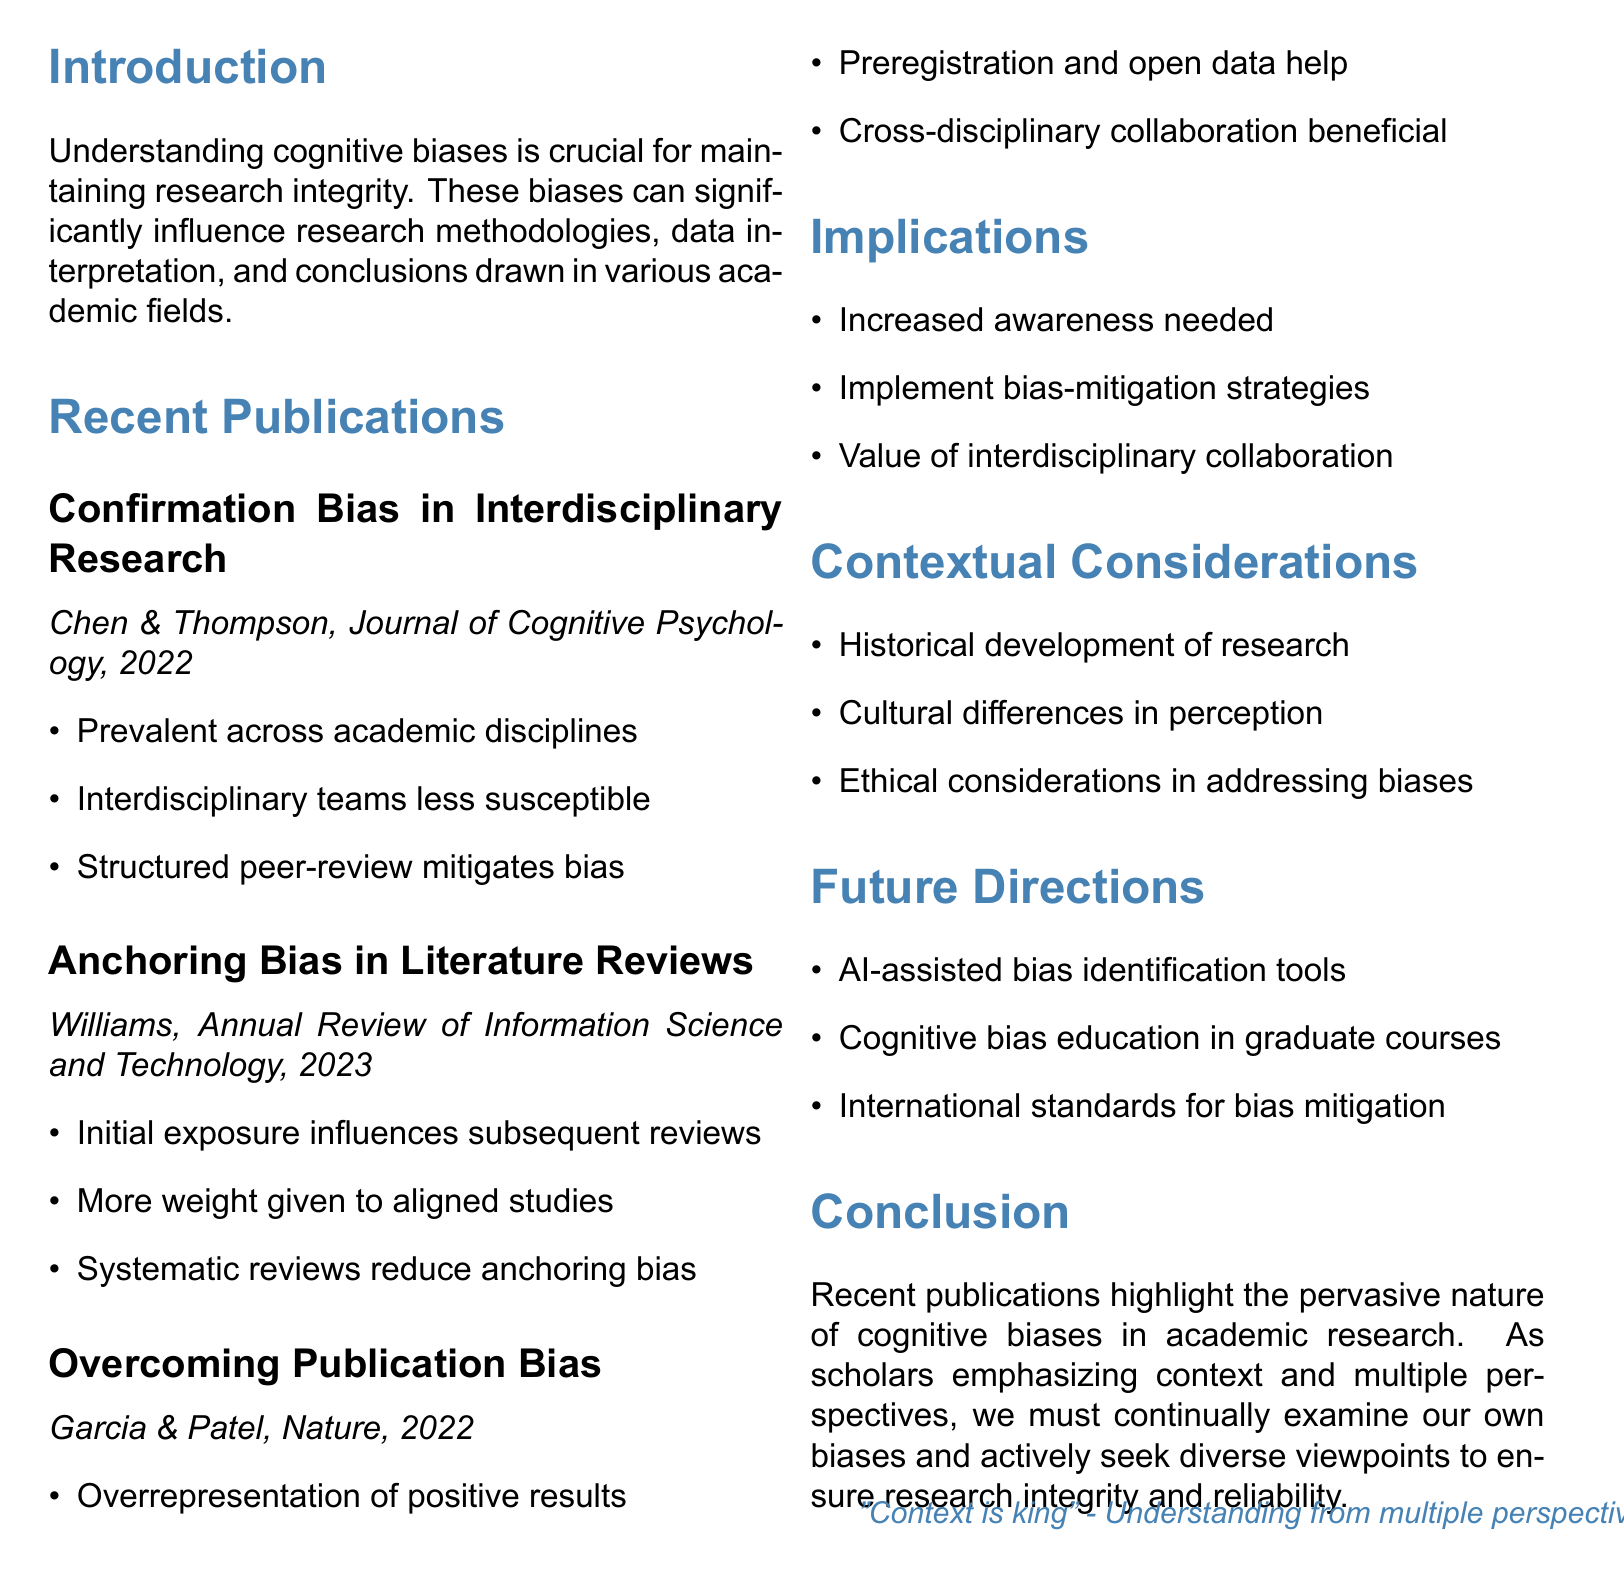what is the title of the memo? The title of the memo is stated at the beginning, summarizing the main focus of the document.
Answer: Review of Recent Publications on Cognitive Biases in Academic Research who are the authors of the publication titled "Confirmation Bias in Interdisciplinary Research"? This information can be found under the section discussing recent publications, which lists the authors of the relevant study.
Answer: Dr. Emily Chen and Dr. Michael Thompson what year was "The Impact of Anchoring Bias on Scientific Literature Reviews" published? The year of publication is provided in the citation of the study mentioned in the document.
Answer: 2023 which bias is mentioned as being mitigated by structured peer-review processes? The information about this bias is included in the key findings of the first publication discussed in the memo.
Answer: Confirmation bias what strategies are proposed to overcome publication bias? The document outlines several strategies in the section on overcoming publication bias.
Answer: Preregistration of studies and open data practices what is the importance of interdisciplinary collaboration mentioned in the implications? The implications section highlights the value of interdisciplinary collaboration concerning cognitive biases in research.
Answer: Reducing the impact of cognitive biases what contextual consideration involves understanding cultural perspectives? The considerations listed focus on various factors influencing cognitive biases, one of which is cultural.
Answer: Cultural differences in the perception and impact of cognitive biases what is a future direction involving AI in cognitive bias research? The future directions section proposes developments that leverage technology to aid in bias identification.
Answer: Development of AI-assisted tools for identifying potential biases in research what type of research methodology is suggested to help reduce anchoring bias? The document specifies a method in the key findings related to the study on anchoring bias.
Answer: Systematic review methodologies 